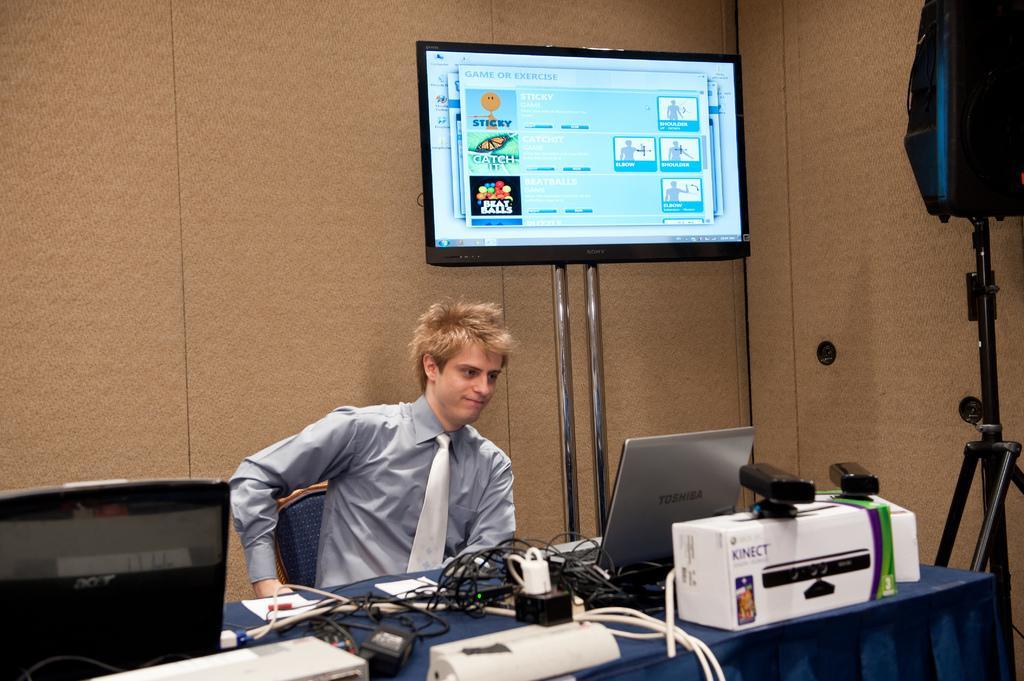Could you give a brief overview of what you see in this image? This is a picture taken in a room, the man is sitting on a chair in front of the man there is a table on the table there are laptop, cables and paper. Background of the man is a wall and a television. 